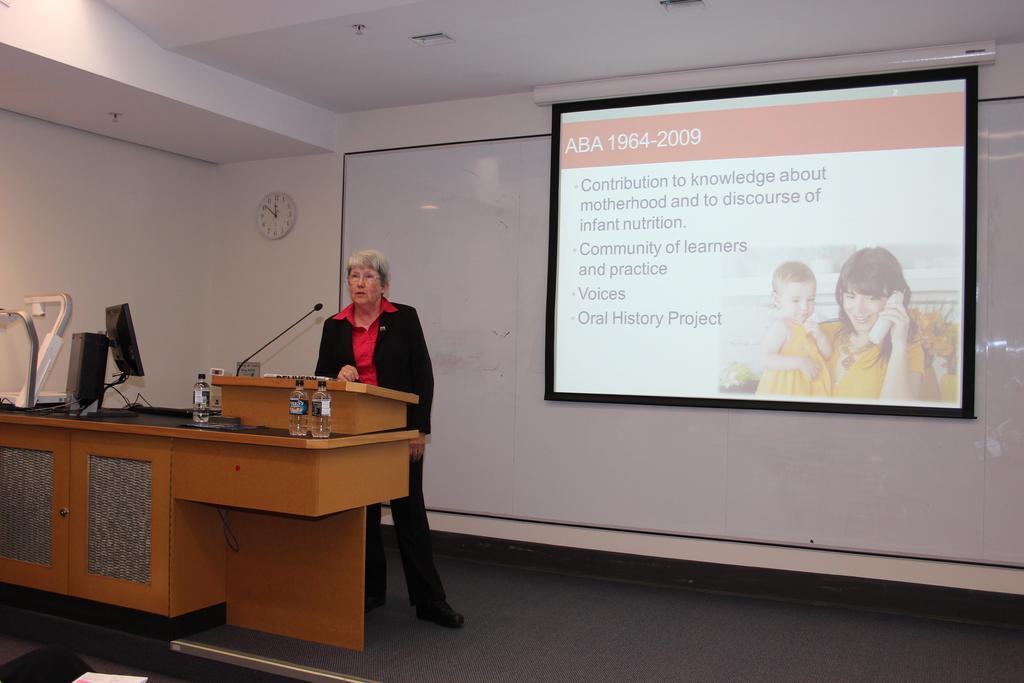Please provide a concise description of this image. This is a picture taken in a seminar hall, the woman in black and red dress standing behind the podium on the there are bottles and microphone. background of the woman is a white board and a projector screen and a white wall on the wall there is a clock. 